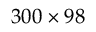Convert formula to latex. <formula><loc_0><loc_0><loc_500><loc_500>3 0 0 \times 9 8</formula> 